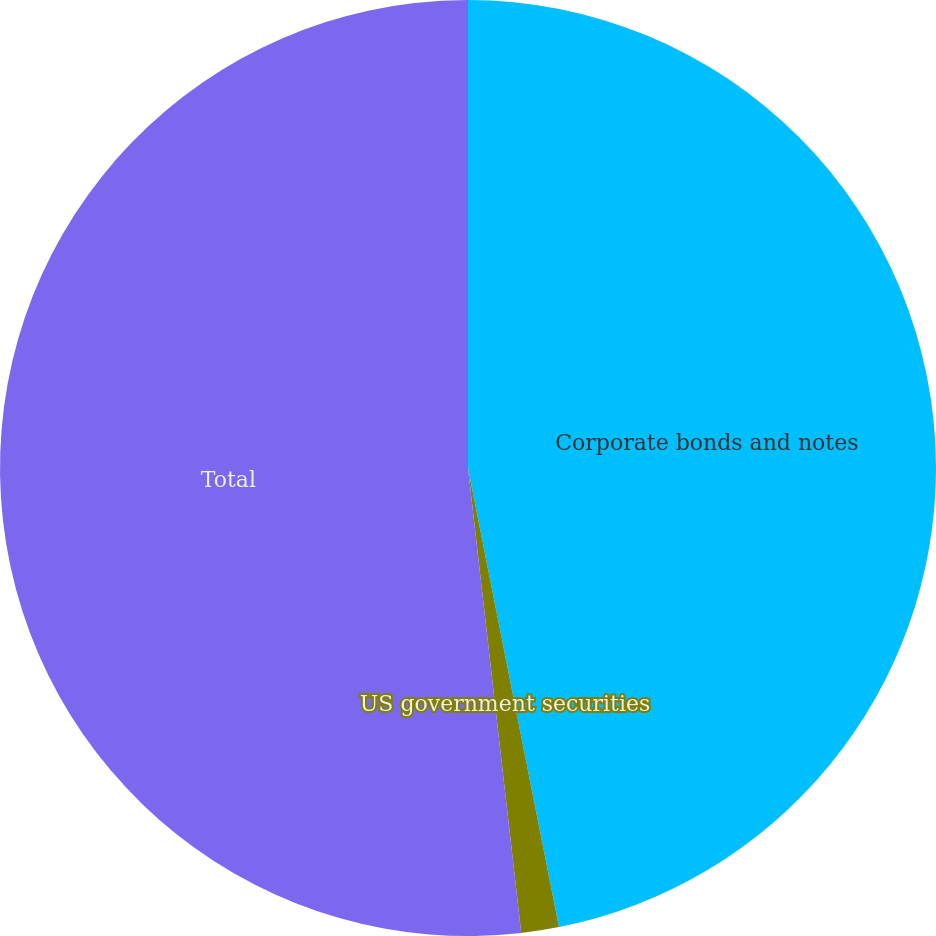<chart> <loc_0><loc_0><loc_500><loc_500><pie_chart><fcel>Corporate bonds and notes<fcel>US government securities<fcel>Total<nl><fcel>46.89%<fcel>1.3%<fcel>51.82%<nl></chart> 